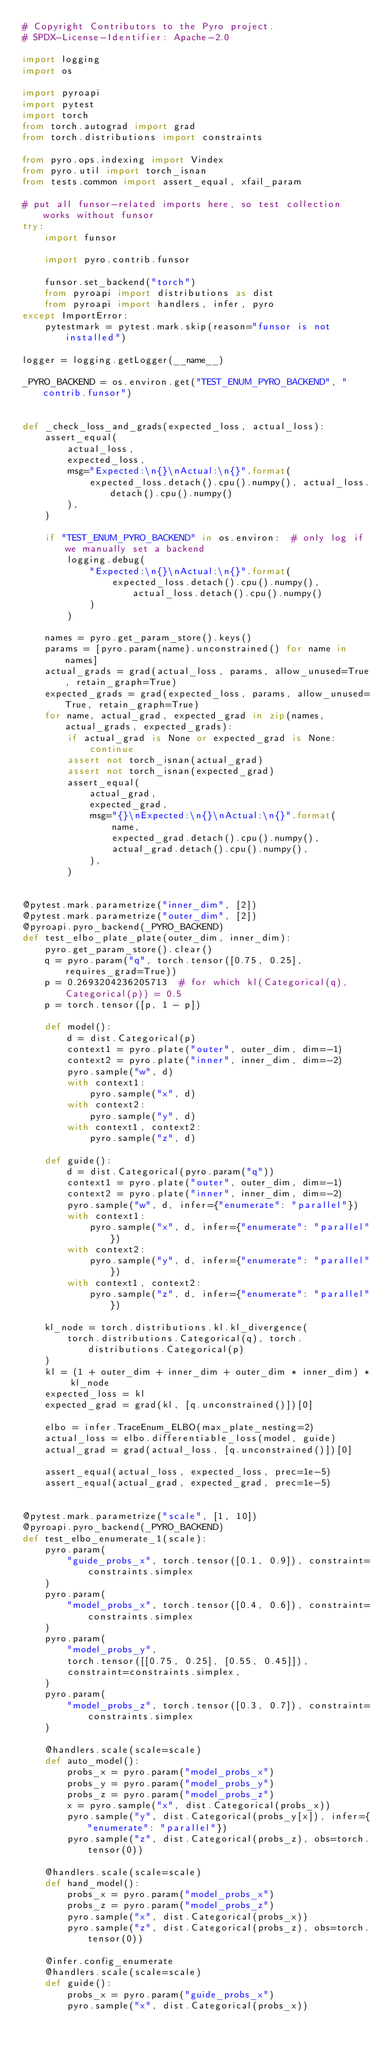<code> <loc_0><loc_0><loc_500><loc_500><_Python_># Copyright Contributors to the Pyro project.
# SPDX-License-Identifier: Apache-2.0

import logging
import os

import pyroapi
import pytest
import torch
from torch.autograd import grad
from torch.distributions import constraints

from pyro.ops.indexing import Vindex
from pyro.util import torch_isnan
from tests.common import assert_equal, xfail_param

# put all funsor-related imports here, so test collection works without funsor
try:
    import funsor

    import pyro.contrib.funsor

    funsor.set_backend("torch")
    from pyroapi import distributions as dist
    from pyroapi import handlers, infer, pyro
except ImportError:
    pytestmark = pytest.mark.skip(reason="funsor is not installed")

logger = logging.getLogger(__name__)

_PYRO_BACKEND = os.environ.get("TEST_ENUM_PYRO_BACKEND", "contrib.funsor")


def _check_loss_and_grads(expected_loss, actual_loss):
    assert_equal(
        actual_loss,
        expected_loss,
        msg="Expected:\n{}\nActual:\n{}".format(
            expected_loss.detach().cpu().numpy(), actual_loss.detach().cpu().numpy()
        ),
    )

    if "TEST_ENUM_PYRO_BACKEND" in os.environ:  # only log if we manually set a backend
        logging.debug(
            "Expected:\n{}\nActual:\n{}".format(
                expected_loss.detach().cpu().numpy(), actual_loss.detach().cpu().numpy()
            )
        )

    names = pyro.get_param_store().keys()
    params = [pyro.param(name).unconstrained() for name in names]
    actual_grads = grad(actual_loss, params, allow_unused=True, retain_graph=True)
    expected_grads = grad(expected_loss, params, allow_unused=True, retain_graph=True)
    for name, actual_grad, expected_grad in zip(names, actual_grads, expected_grads):
        if actual_grad is None or expected_grad is None:
            continue
        assert not torch_isnan(actual_grad)
        assert not torch_isnan(expected_grad)
        assert_equal(
            actual_grad,
            expected_grad,
            msg="{}\nExpected:\n{}\nActual:\n{}".format(
                name,
                expected_grad.detach().cpu().numpy(),
                actual_grad.detach().cpu().numpy(),
            ),
        )


@pytest.mark.parametrize("inner_dim", [2])
@pytest.mark.parametrize("outer_dim", [2])
@pyroapi.pyro_backend(_PYRO_BACKEND)
def test_elbo_plate_plate(outer_dim, inner_dim):
    pyro.get_param_store().clear()
    q = pyro.param("q", torch.tensor([0.75, 0.25], requires_grad=True))
    p = 0.2693204236205713  # for which kl(Categorical(q), Categorical(p)) = 0.5
    p = torch.tensor([p, 1 - p])

    def model():
        d = dist.Categorical(p)
        context1 = pyro.plate("outer", outer_dim, dim=-1)
        context2 = pyro.plate("inner", inner_dim, dim=-2)
        pyro.sample("w", d)
        with context1:
            pyro.sample("x", d)
        with context2:
            pyro.sample("y", d)
        with context1, context2:
            pyro.sample("z", d)

    def guide():
        d = dist.Categorical(pyro.param("q"))
        context1 = pyro.plate("outer", outer_dim, dim=-1)
        context2 = pyro.plate("inner", inner_dim, dim=-2)
        pyro.sample("w", d, infer={"enumerate": "parallel"})
        with context1:
            pyro.sample("x", d, infer={"enumerate": "parallel"})
        with context2:
            pyro.sample("y", d, infer={"enumerate": "parallel"})
        with context1, context2:
            pyro.sample("z", d, infer={"enumerate": "parallel"})

    kl_node = torch.distributions.kl.kl_divergence(
        torch.distributions.Categorical(q), torch.distributions.Categorical(p)
    )
    kl = (1 + outer_dim + inner_dim + outer_dim * inner_dim) * kl_node
    expected_loss = kl
    expected_grad = grad(kl, [q.unconstrained()])[0]

    elbo = infer.TraceEnum_ELBO(max_plate_nesting=2)
    actual_loss = elbo.differentiable_loss(model, guide)
    actual_grad = grad(actual_loss, [q.unconstrained()])[0]

    assert_equal(actual_loss, expected_loss, prec=1e-5)
    assert_equal(actual_grad, expected_grad, prec=1e-5)


@pytest.mark.parametrize("scale", [1, 10])
@pyroapi.pyro_backend(_PYRO_BACKEND)
def test_elbo_enumerate_1(scale):
    pyro.param(
        "guide_probs_x", torch.tensor([0.1, 0.9]), constraint=constraints.simplex
    )
    pyro.param(
        "model_probs_x", torch.tensor([0.4, 0.6]), constraint=constraints.simplex
    )
    pyro.param(
        "model_probs_y",
        torch.tensor([[0.75, 0.25], [0.55, 0.45]]),
        constraint=constraints.simplex,
    )
    pyro.param(
        "model_probs_z", torch.tensor([0.3, 0.7]), constraint=constraints.simplex
    )

    @handlers.scale(scale=scale)
    def auto_model():
        probs_x = pyro.param("model_probs_x")
        probs_y = pyro.param("model_probs_y")
        probs_z = pyro.param("model_probs_z")
        x = pyro.sample("x", dist.Categorical(probs_x))
        pyro.sample("y", dist.Categorical(probs_y[x]), infer={"enumerate": "parallel"})
        pyro.sample("z", dist.Categorical(probs_z), obs=torch.tensor(0))

    @handlers.scale(scale=scale)
    def hand_model():
        probs_x = pyro.param("model_probs_x")
        probs_z = pyro.param("model_probs_z")
        pyro.sample("x", dist.Categorical(probs_x))
        pyro.sample("z", dist.Categorical(probs_z), obs=torch.tensor(0))

    @infer.config_enumerate
    @handlers.scale(scale=scale)
    def guide():
        probs_x = pyro.param("guide_probs_x")
        pyro.sample("x", dist.Categorical(probs_x))
</code> 